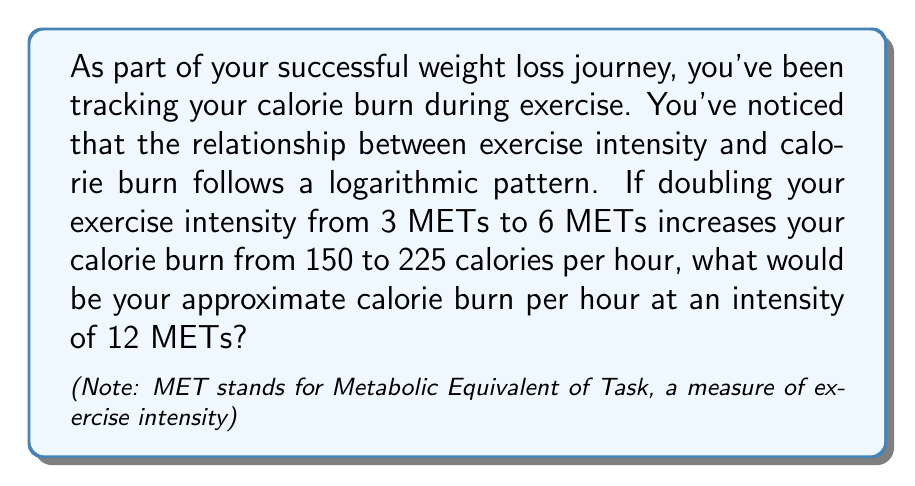Can you solve this math problem? Let's approach this step-by-step using the properties of logarithms:

1) We can model this relationship using the logarithmic function:
   $$ C = a \log_2(I) + b $$
   Where $C$ is calories burned per hour, $I$ is intensity in METs, and $a$ and $b$ are constants we need to determine.

2) We have two known points: (3, 150) and (6, 225). Let's use these to find $a$ and $b$.

3) For the first point:
   $$ 150 = a \log_2(3) + b $$

4) For the second point:
   $$ 225 = a \log_2(6) + b $$

5) Subtracting the first equation from the second:
   $$ 225 - 150 = a(\log_2(6) - \log_2(3)) $$
   $$ 75 = a(\log_2(2)) $$
   $$ 75 = a $$

6) Now we can substitute this back into either equation to find $b$:
   $$ 150 = 75 \log_2(3) + b $$
   $$ b = 150 - 75 \log_2(3) \approx 31.14 $$

7) Our final equation is:
   $$ C = 75 \log_2(I) + 31.14 $$

8) To find the calorie burn at 12 METs:
   $$ C = 75 \log_2(12) + 31.14 $$
   $$ C = 75 * 3.58 + 31.14 $$
   $$ C \approx 299.64 $$
Answer: Approximately 300 calories per hour 